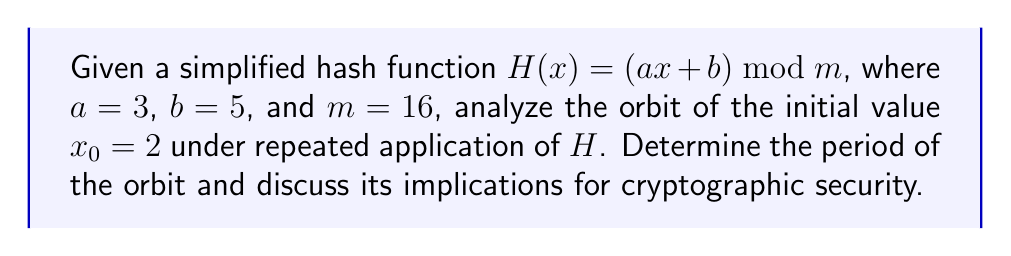Teach me how to tackle this problem. Let's approach this step-by-step:

1) First, we need to iterate the hash function starting with $x_0 = 2$:

   $x_1 = H(x_0) = (3 \cdot 2 + 5) \bmod 16 = 11$
   $x_2 = H(x_1) = (3 \cdot 11 + 5) \bmod 16 = 6$
   $x_3 = H(x_2) = (3 \cdot 6 + 5) \bmod 16 = 7$
   $x_4 = H(x_3) = (3 \cdot 7 + 5) \bmod 16 = 10$
   $x_5 = H(x_4) = (3 \cdot 10 + 5) \bmod 16 = 3$
   $x_6 = H(x_5) = (3 \cdot 3 + 5) \bmod 16 = 14$
   $x_7 = H(x_6) = (3 \cdot 14 + 5) \bmod 16 = 11$

2) We observe that $x_7 = x_1 = 11$. This means the sequence has entered a cycle.

3) The period of the orbit is the length of this cycle. In this case, it's 6 (from $x_1$ to $x_6$).

4) The complete orbit is: 2 → 11 → 6 → 7 → 10 → 3 → 14 → 11 → ...

5) Implications for cryptographic security:
   - A short period (6 in this case) means the hash function is highly predictable.
   - It only explores 7 out of 16 possible values, showing poor distribution.
   - The function is easily reversible within the cycle, compromising one-way property.
   - Such a function would be extremely weak for cryptographic purposes, as it lacks the chaos and unpredictability required for secure hashing.

6) In practice, cryptographic hash functions use much more complex operations and larger moduli to achieve the desired chaotic behavior and security properties.
Answer: Period: 6. Cryptographically weak due to short cycle and predictability. 